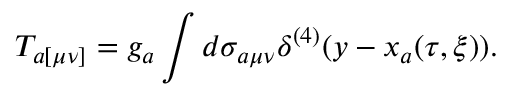<formula> <loc_0><loc_0><loc_500><loc_500>T _ { a [ \mu \nu ] } = g _ { a } \int d \sigma _ { a \mu \nu } \delta ^ { ( 4 ) } ( y - x _ { a } ( \tau , \xi ) ) .</formula> 